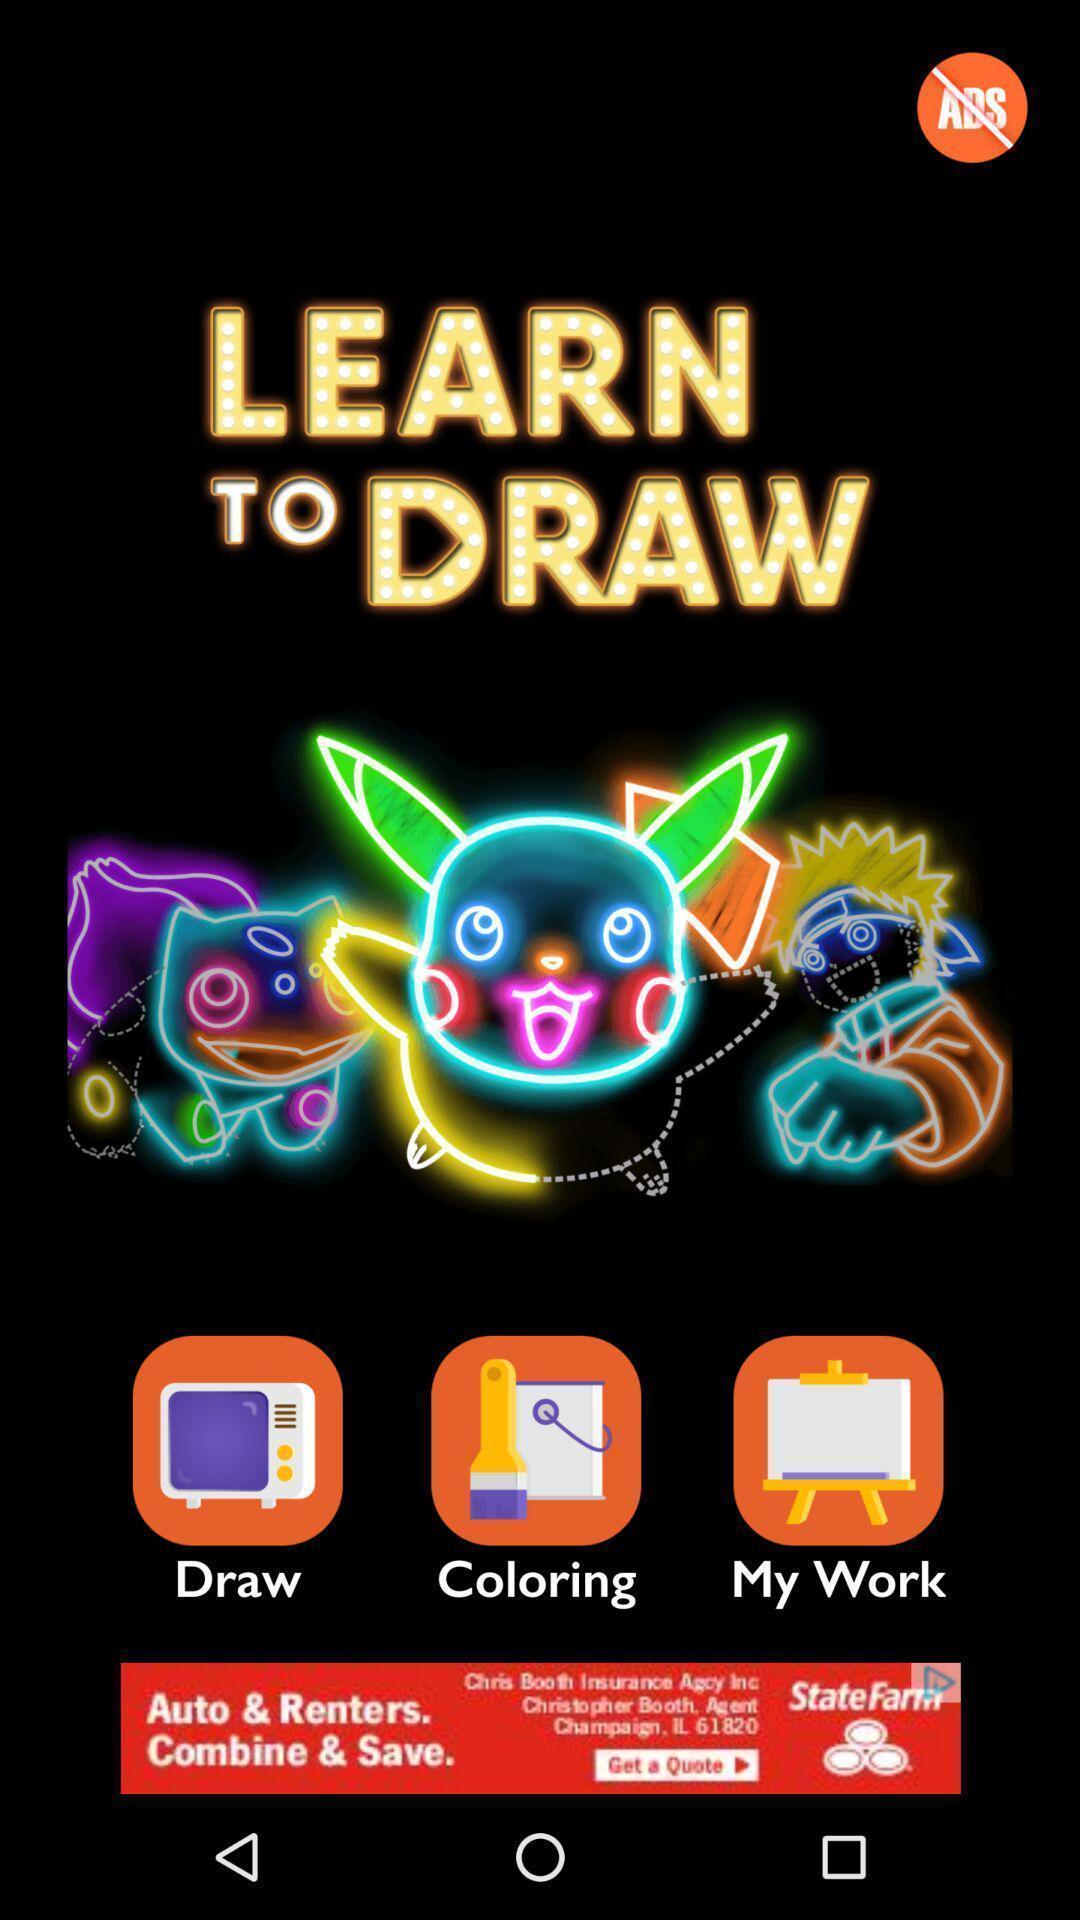Provide a textual representation of this image. Screen showing page of an drawing application. 